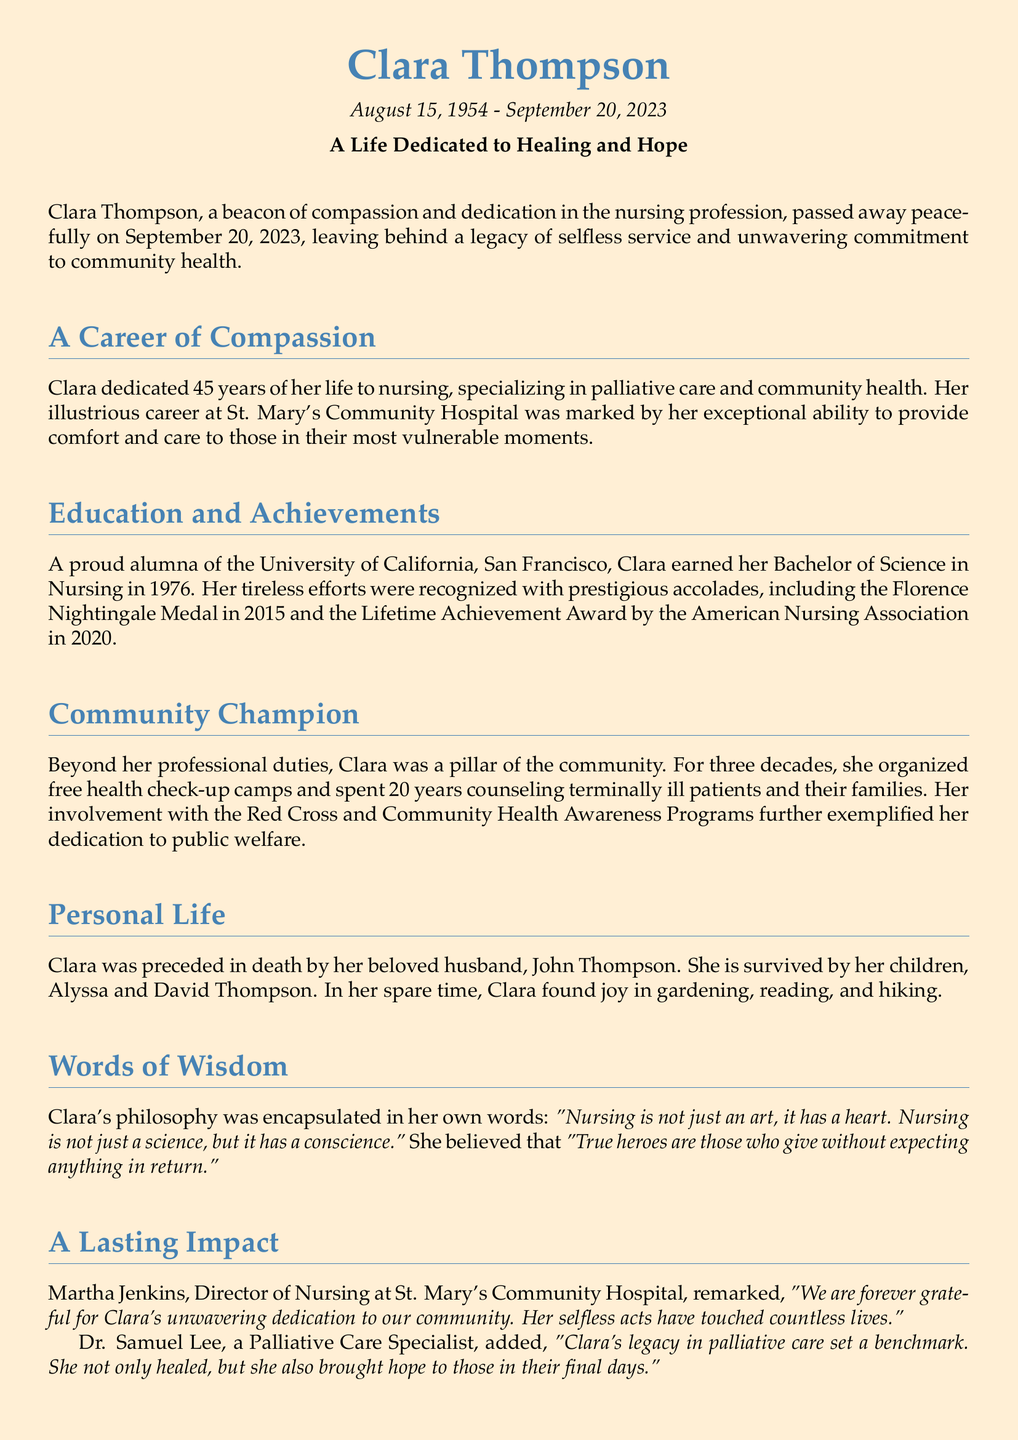What was Clara Thompson's profession? Clara Thompson dedicated her career to nursing, specifically in palliative care and community health.
Answer: Nursing How many years did Clara serve in her profession? Clara served 45 years in nursing, as mentioned in the document.
Answer: 45 years Which award did Clara receive in 2015? Clara was honored with the Florence Nightingale Medal in 2015.
Answer: Florence Nightingale Medal What philosophy did Clara express about nursing? Clara believed that "Nursing is not just an art, it has a heart. Nursing is not just a science, but it has a conscience."
Answer: "Nursing is not just an art, it has a heart." Who described Clara's legacy in palliative care? Dr. Samuel Lee, a Palliative Care Specialist, remarked about Clara's legacy in palliative care.
Answer: Dr. Samuel Lee What community activities did Clara participate in? Clara organized free health check-up camps and counseled terminally ill patients and their families.
Answer: Free health check-up camps When did Clara Thompson pass away? Clara Thompson passed away on September 20, 2023.
Answer: September 20, 2023 Who was Clara's husband? Clara was preceded in death by her beloved husband, John Thompson.
Answer: John Thompson How many children did Clara have? Clara had two children, Alyssa and David Thompson.
Answer: Two children What was Clara's degree in? Clara earned her Bachelor of Science in Nursing.
Answer: Bachelor of Science in Nursing 